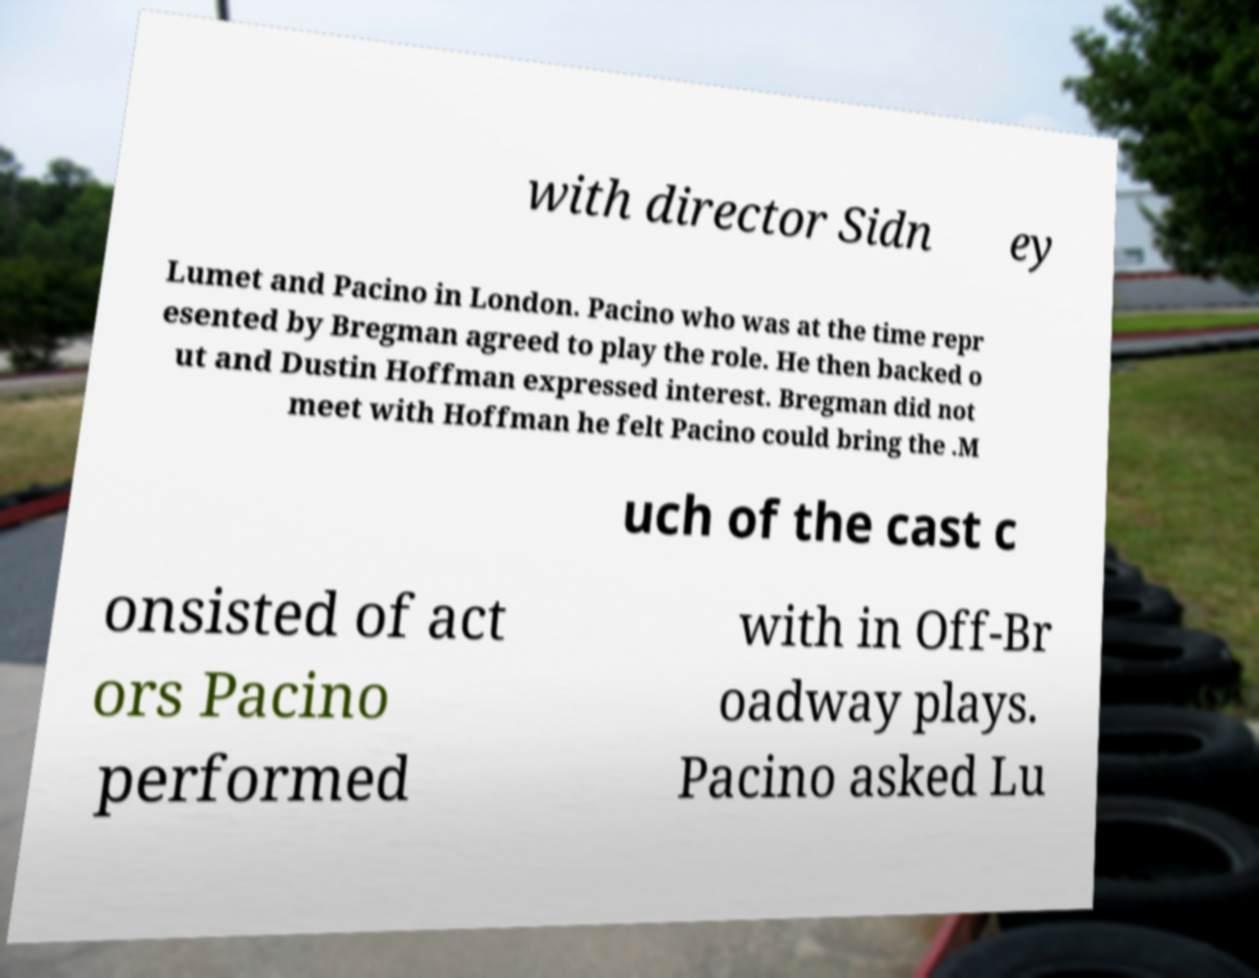For documentation purposes, I need the text within this image transcribed. Could you provide that? with director Sidn ey Lumet and Pacino in London. Pacino who was at the time repr esented by Bregman agreed to play the role. He then backed o ut and Dustin Hoffman expressed interest. Bregman did not meet with Hoffman he felt Pacino could bring the .M uch of the cast c onsisted of act ors Pacino performed with in Off-Br oadway plays. Pacino asked Lu 